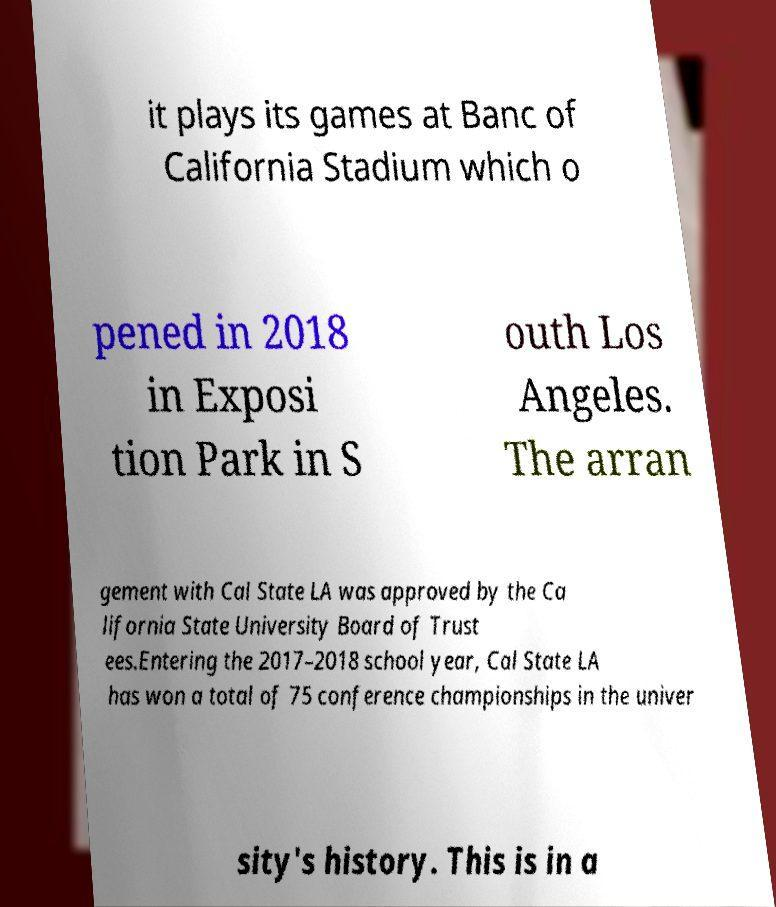For documentation purposes, I need the text within this image transcribed. Could you provide that? it plays its games at Banc of California Stadium which o pened in 2018 in Exposi tion Park in S outh Los Angeles. The arran gement with Cal State LA was approved by the Ca lifornia State University Board of Trust ees.Entering the 2017–2018 school year, Cal State LA has won a total of 75 conference championships in the univer sity's history. This is in a 